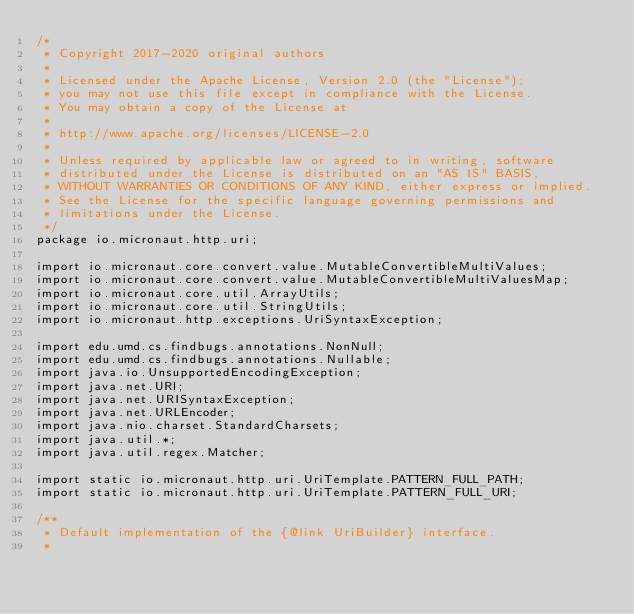Convert code to text. <code><loc_0><loc_0><loc_500><loc_500><_Java_>/*
 * Copyright 2017-2020 original authors
 *
 * Licensed under the Apache License, Version 2.0 (the "License");
 * you may not use this file except in compliance with the License.
 * You may obtain a copy of the License at
 *
 * http://www.apache.org/licenses/LICENSE-2.0
 *
 * Unless required by applicable law or agreed to in writing, software
 * distributed under the License is distributed on an "AS IS" BASIS,
 * WITHOUT WARRANTIES OR CONDITIONS OF ANY KIND, either express or implied.
 * See the License for the specific language governing permissions and
 * limitations under the License.
 */
package io.micronaut.http.uri;

import io.micronaut.core.convert.value.MutableConvertibleMultiValues;
import io.micronaut.core.convert.value.MutableConvertibleMultiValuesMap;
import io.micronaut.core.util.ArrayUtils;
import io.micronaut.core.util.StringUtils;
import io.micronaut.http.exceptions.UriSyntaxException;

import edu.umd.cs.findbugs.annotations.NonNull;
import edu.umd.cs.findbugs.annotations.Nullable;
import java.io.UnsupportedEncodingException;
import java.net.URI;
import java.net.URISyntaxException;
import java.net.URLEncoder;
import java.nio.charset.StandardCharsets;
import java.util.*;
import java.util.regex.Matcher;

import static io.micronaut.http.uri.UriTemplate.PATTERN_FULL_PATH;
import static io.micronaut.http.uri.UriTemplate.PATTERN_FULL_URI;

/**
 * Default implementation of the {@link UriBuilder} interface.
 *</code> 